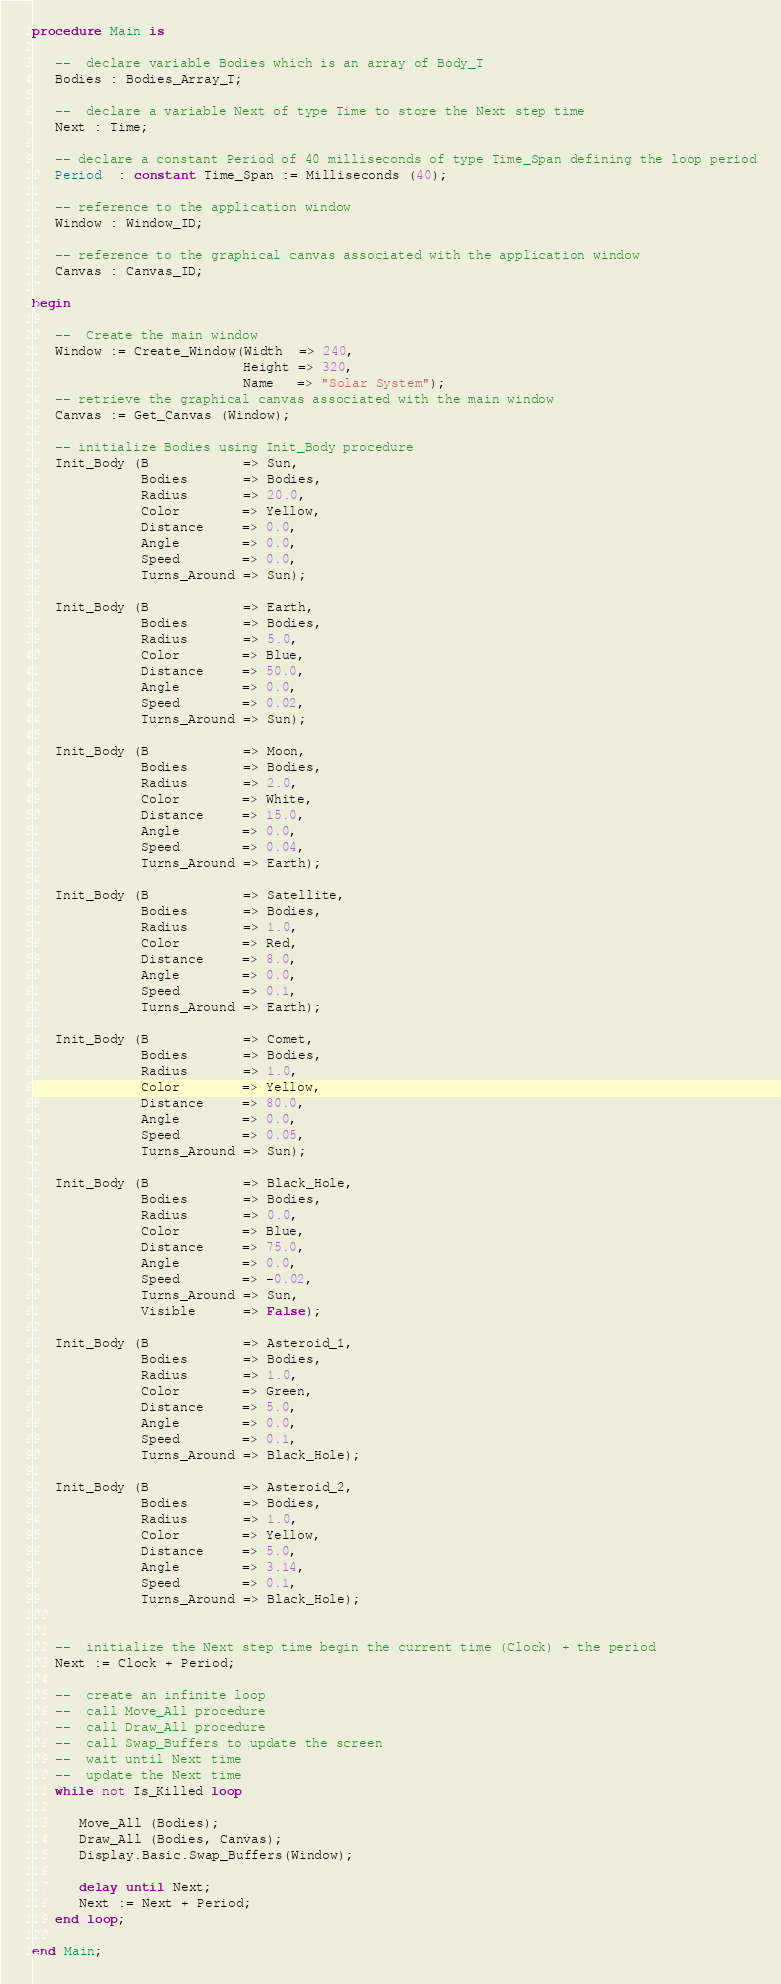<code> <loc_0><loc_0><loc_500><loc_500><_Ada_>
procedure Main is

   --  declare variable Bodies which is an array of Body_T
   Bodies : Bodies_Array_T;

   --  declare a variable Next of type Time to store the Next step time
   Next : Time;

   -- declare a constant Period of 40 milliseconds of type Time_Span defining the loop period
   Period  : constant Time_Span := Milliseconds (40);

   -- reference to the application window
   Window : Window_ID;

   -- reference to the graphical canvas associated with the application window
   Canvas : Canvas_ID;

begin

   --  Create the main window
   Window := Create_Window(Width  => 240,
                           Height => 320,
                           Name   => "Solar System");
   -- retrieve the graphical canvas associated with the main window
   Canvas := Get_Canvas (Window);

   -- initialize Bodies using Init_Body procedure
   Init_Body (B            => Sun,
              Bodies       => Bodies,
              Radius       => 20.0,
              Color        => Yellow,
              Distance     => 0.0,
              Angle        => 0.0,
              Speed        => 0.0,
              Turns_Around => Sun);

   Init_Body (B            => Earth,
              Bodies       => Bodies,
              Radius       => 5.0,
              Color        => Blue,
              Distance     => 50.0,
              Angle        => 0.0,
              Speed        => 0.02,
              Turns_Around => Sun);

   Init_Body (B            => Moon,
              Bodies       => Bodies,
              Radius       => 2.0,
              Color        => White,
              Distance     => 15.0,
              Angle        => 0.0,
              Speed        => 0.04,
              Turns_Around => Earth);

   Init_Body (B            => Satellite,
              Bodies       => Bodies,
              Radius       => 1.0,
              Color        => Red,
              Distance     => 8.0,
              Angle        => 0.0,
              Speed        => 0.1,
              Turns_Around => Earth);

   Init_Body (B            => Comet,
              Bodies       => Bodies,
              Radius       => 1.0,
              Color        => Yellow,
              Distance     => 80.0,
              Angle        => 0.0,
              Speed        => 0.05,
              Turns_Around => Sun);

   Init_Body (B            => Black_Hole,
              Bodies       => Bodies,
              Radius       => 0.0,
              Color        => Blue,
              Distance     => 75.0,
              Angle        => 0.0,
              Speed        => -0.02,
              Turns_Around => Sun,
              Visible      => False);

   Init_Body (B            => Asteroid_1,
              Bodies       => Bodies,
              Radius       => 1.0,
              Color        => Green,
              Distance     => 5.0,
              Angle        => 0.0,
              Speed        => 0.1,
              Turns_Around => Black_Hole);

   Init_Body (B            => Asteroid_2,
              Bodies       => Bodies,
              Radius       => 1.0,
              Color        => Yellow,
              Distance     => 5.0,
              Angle        => 3.14,
              Speed        => 0.1,
              Turns_Around => Black_Hole);


   --  initialize the Next step time begin the current time (Clock) + the period
   Next := Clock + Period;

   --  create an infinite loop
   --  call Move_All procedure
   --  call Draw_All procedure
   --  call Swap_Buffers to update the screen
   --  wait until Next time
   --  update the Next time
   while not Is_Killed loop

      Move_All (Bodies);
      Draw_All (Bodies, Canvas);
      Display.Basic.Swap_Buffers(Window);

      delay until Next;
      Next := Next + Period;
   end loop;

end Main;
</code> 